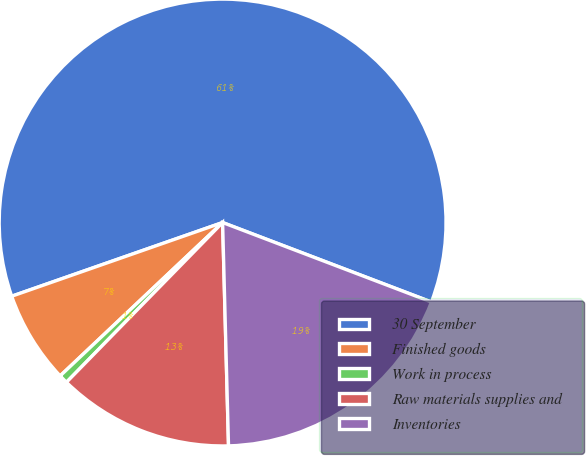Convert chart. <chart><loc_0><loc_0><loc_500><loc_500><pie_chart><fcel>30 September<fcel>Finished goods<fcel>Work in process<fcel>Raw materials supplies and<fcel>Inventories<nl><fcel>61.14%<fcel>6.69%<fcel>0.64%<fcel>12.74%<fcel>18.79%<nl></chart> 